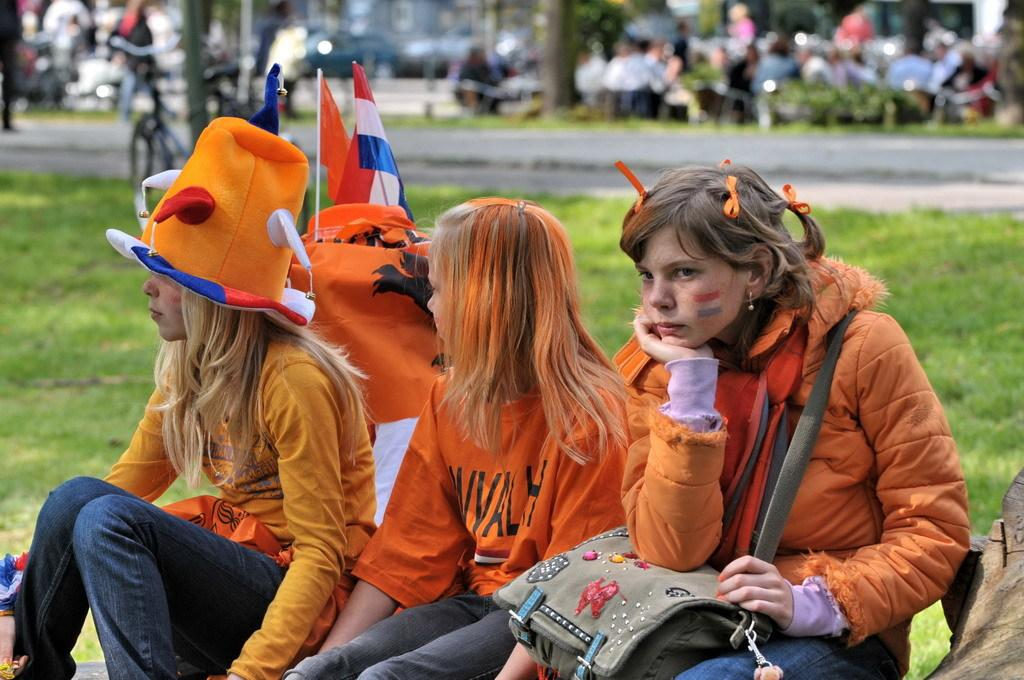How many girls are sitting on the ground in the image? There are three girls sitting on the ground in the image. What can be seen in the background of the image? In the background of the image, there is a bicycle, persons, a road, vehicles, and a building. What is the overall theme of the image? The image depicts a trip. What type of wire can be seen connecting the girls in the image? There is no wire connecting the girls in the image. What suggestion can be made to improve the girls' experience during the trip? The image does not provide enough information to make a suggestion for improving the girls' experience during the trip. 